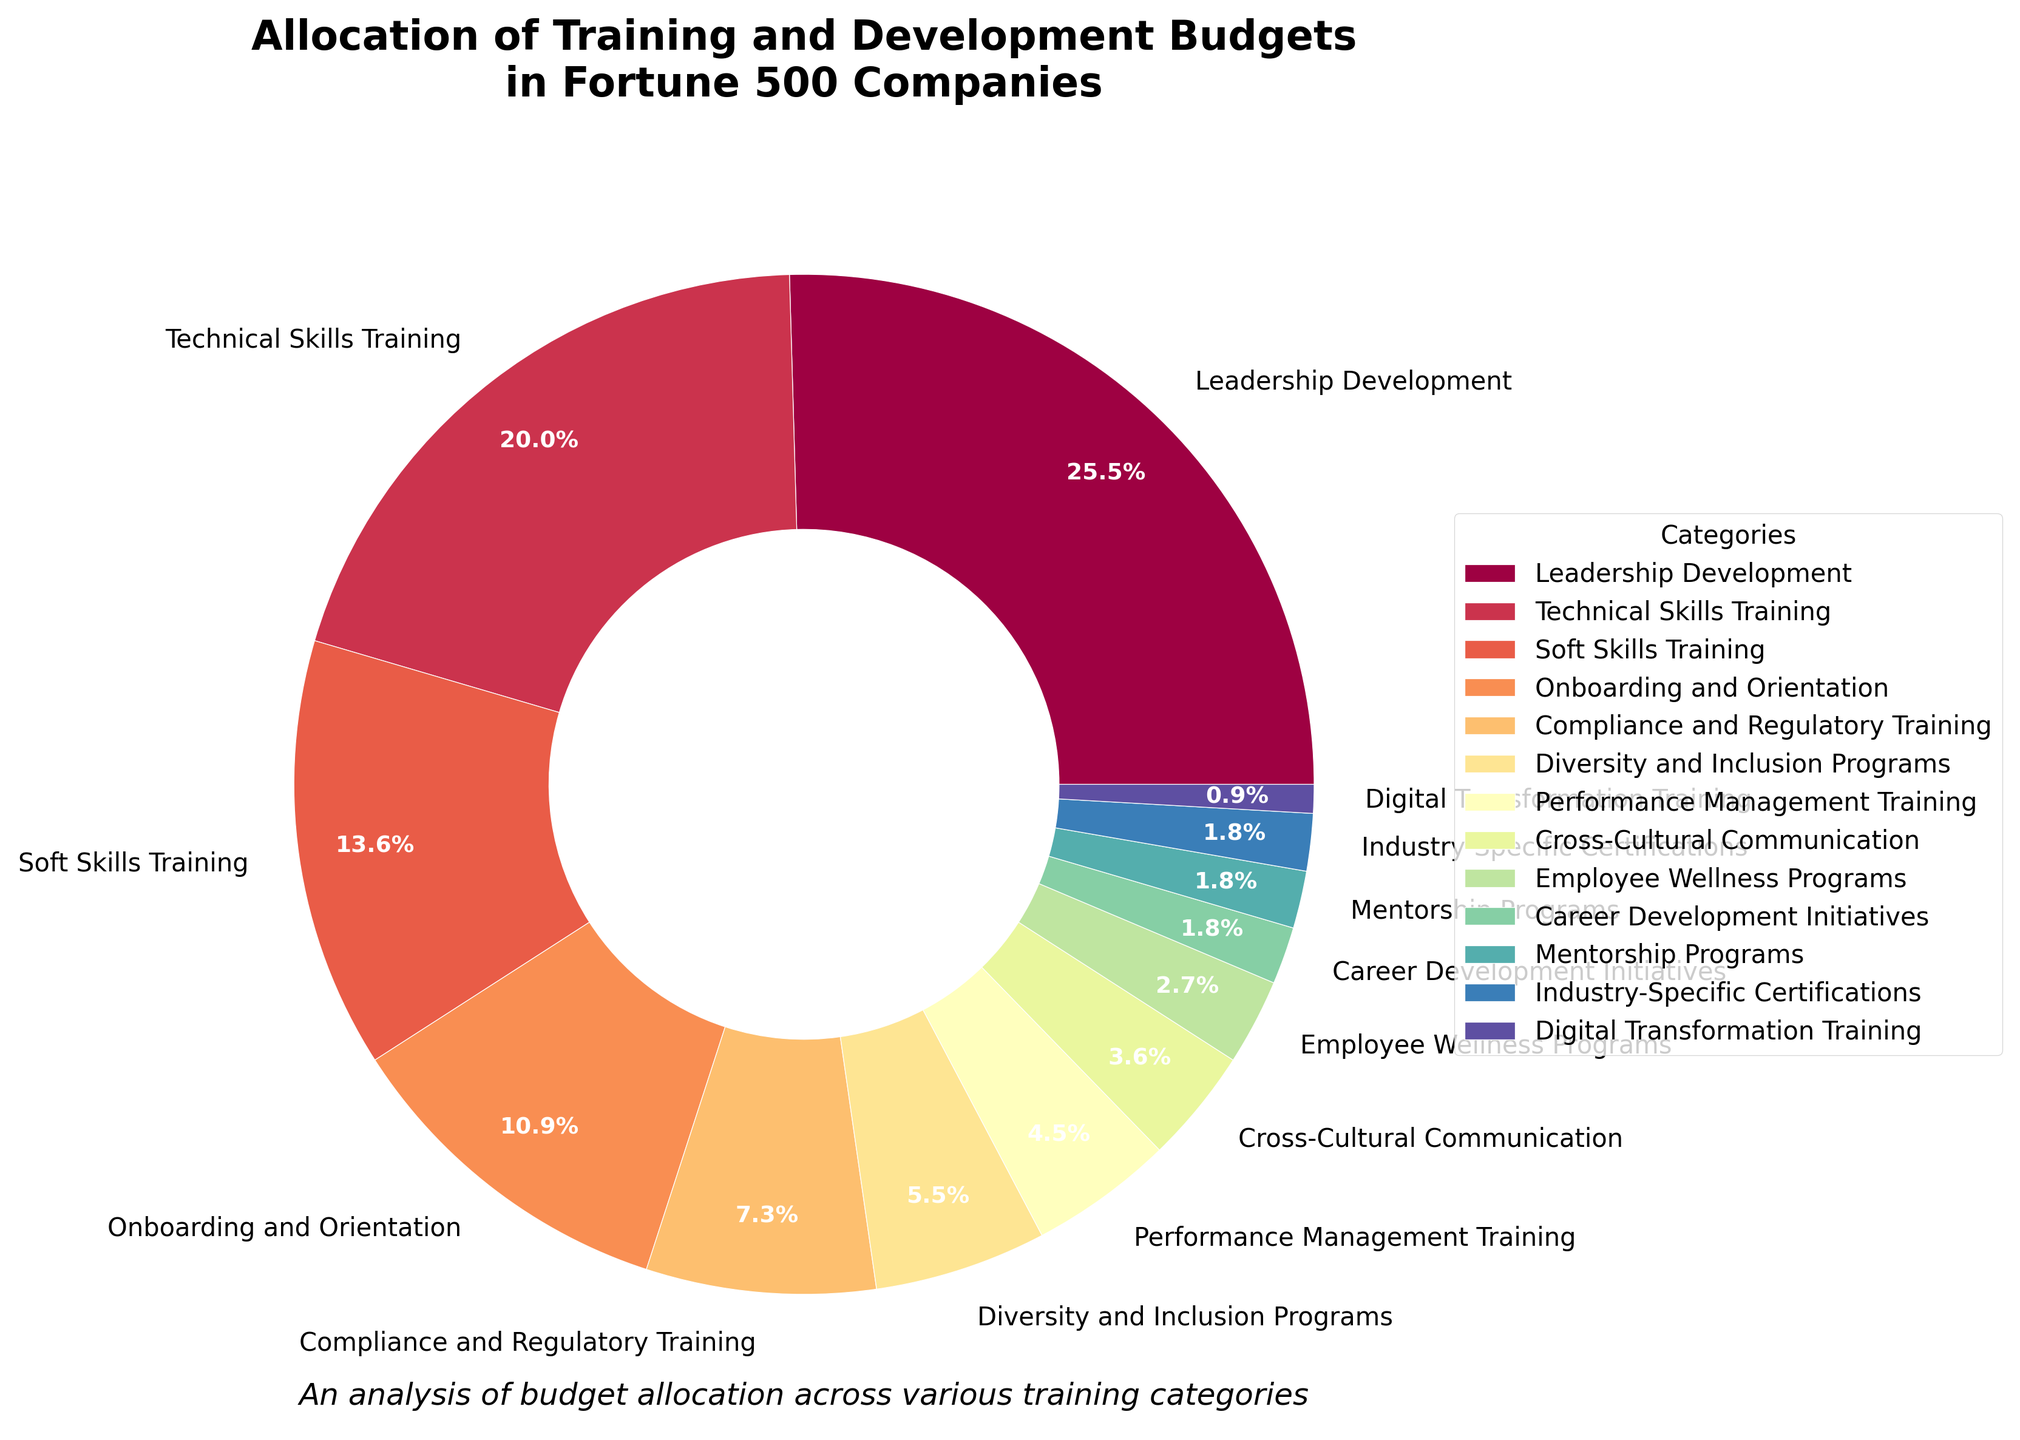What category receives the largest allocation? The largest slice on the pie chart corresponds to "Leadership Development". The label shows 28%, which is the highest percentage among all categories.
Answer: Leadership Development How much more is allocated to Technical Skills Training than Compliance and Regulatory Training? Technical Skills Training has a 22% allocation, while Compliance and Regulatory Training has an 8% allocation. The difference between these two is 22% - 8% = 14%.
Answer: 14% Which category has the smallest allocation? The smallest slice on the pie chart corresponds to "Digital Transformation Training", which has a 1% allocation. This is the lowest percentage among all categories.
Answer: Digital Transformation Training What is the combined percentage of the three smallest categories? The three smallest categories are Digital Transformation Training (1%), Career Development Initiatives (2%), and Mentorship Programs (2%). Their combined percentage is 1% + 2% + 2% = 5%.
Answer: 5% Is the allocation for Onboarding and Orientation higher or lower than that for Soft Skills Training? Onboarding and Orientation has a 12% allocation, while Soft Skills Training has a 15% allocation. Therefore, Onboarding and Orientation is lower.
Answer: Lower What is the percentage difference between Diversity and Inclusion Programs and Performance Management Training? Diversity and Inclusion Programs have a 6% allocation, while Performance Management Training has a 5% allocation. The difference between these two is 6% - 5% = 1%.
Answer: 1% Which two categories have an equal allocation percentage? Both Career Development Initiatives and Mentorship Programs have an allocation of 2%.
Answer: Career Development Initiatives and Mentorship Programs What is the total allocation percentage for all technical-related training categories (Technical Skills Training and Digital Transformation Training)? Technical Skills Training has a 22% allocation, and Digital Transformation Training has a 1% allocation. Adding them together results in a total of 22% + 1% = 23%.
Answer: 23% How much more percentage is allocated to Leadership Development compared to Cross-Cultural Communication? Leadership Development has a 28% allocation, while Cross-Cultural Communication has a 4% allocation. The difference in percentage is 28% - 4% = 24%.
Answer: 24% 